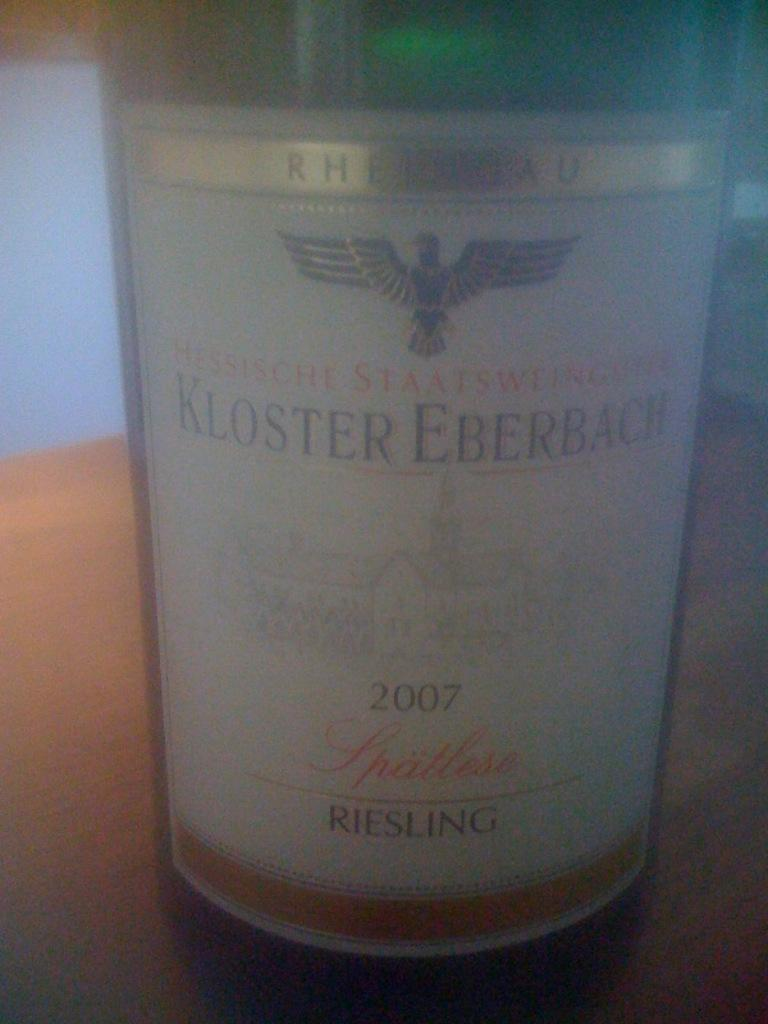<image>
Give a short and clear explanation of the subsequent image. a bottle of alcohol called kloster eberbach made in 2007 